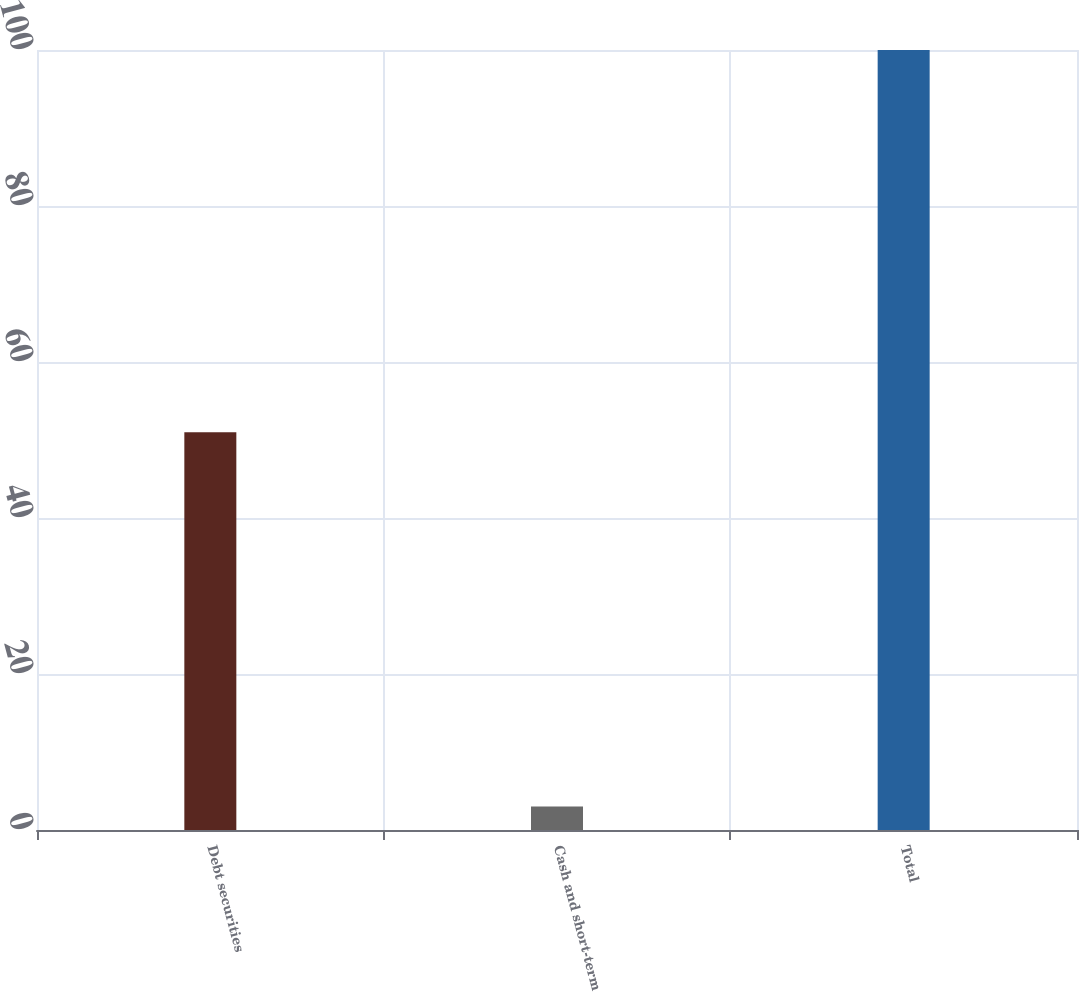<chart> <loc_0><loc_0><loc_500><loc_500><bar_chart><fcel>Debt securities<fcel>Cash and short-term<fcel>Total<nl><fcel>51<fcel>3<fcel>100<nl></chart> 